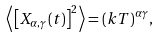Convert formula to latex. <formula><loc_0><loc_0><loc_500><loc_500>\left \langle \left [ X _ { \alpha , \gamma } ( t ) \right ] ^ { 2 } \right \rangle = ( k T ) ^ { \alpha \gamma } ,</formula> 